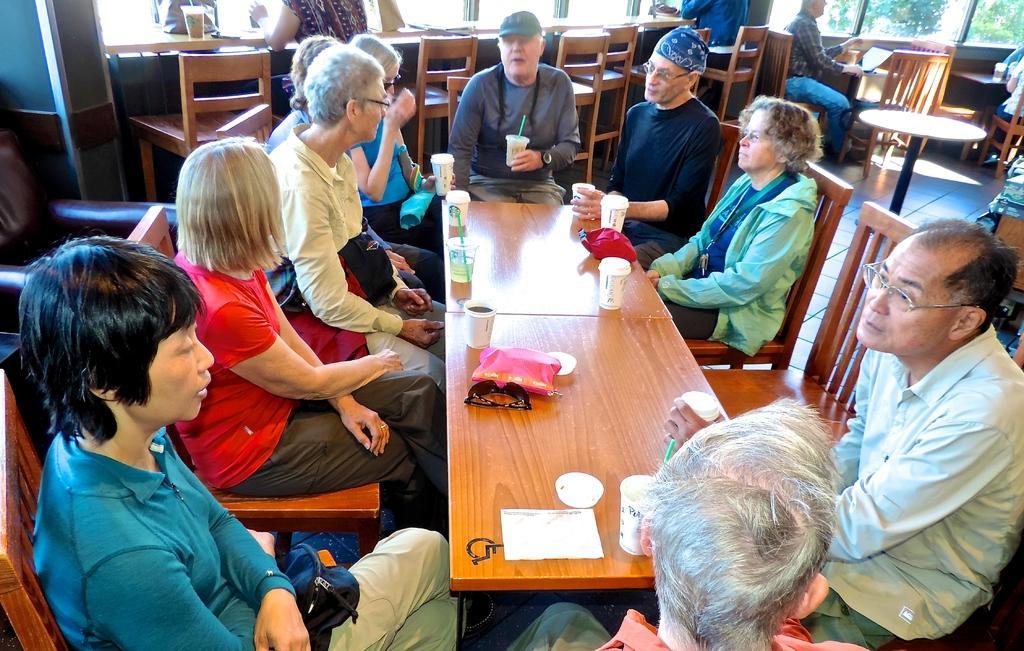Can you describe this image briefly? In this picture there are group of people sitting on a chair. There is a cup, spectacle, paper,straw, pink and red bag on the table. There is a laptop on the table. There are few people sitting on the chair and a tree in the background. 